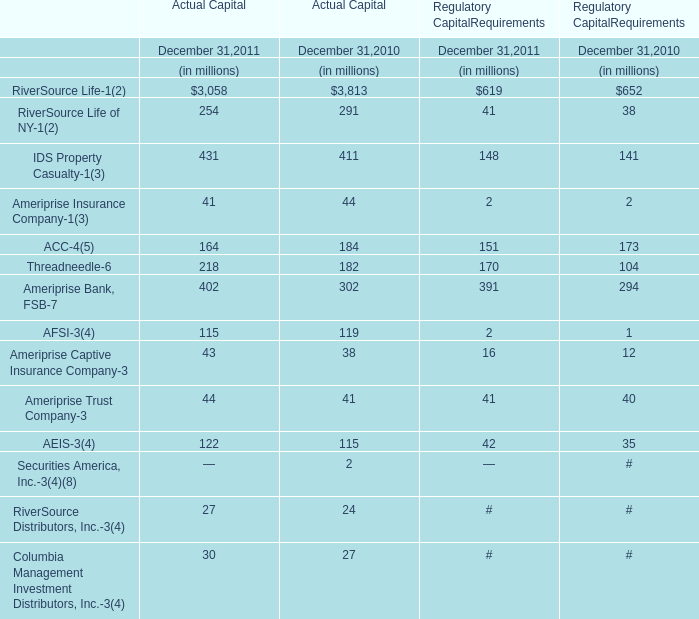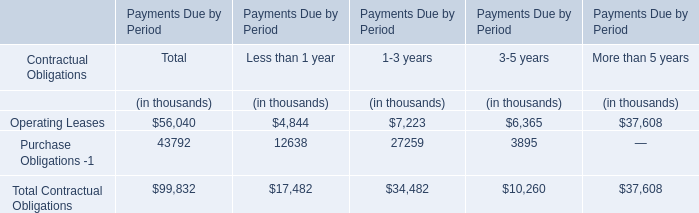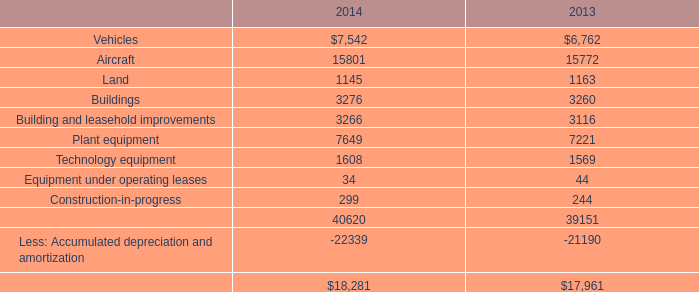What is the proportion of RiverSource Life in Actual Capital to the total in 2011? 
Computations: (3058 / ((((((((((((3058 + 254) + 431) + 41) + 164) + 218) + 402) + 115) + 43) + 44) + 122) + 27) + 30))
Answer: 0.6179. 